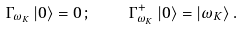<formula> <loc_0><loc_0><loc_500><loc_500>\Gamma _ { \omega _ { K } } \left | 0 \right \rangle = 0 \, ; \quad \Gamma ^ { + } _ { \omega _ { K } } \left | 0 \right \rangle = \left | \omega _ { K } \right \rangle .</formula> 